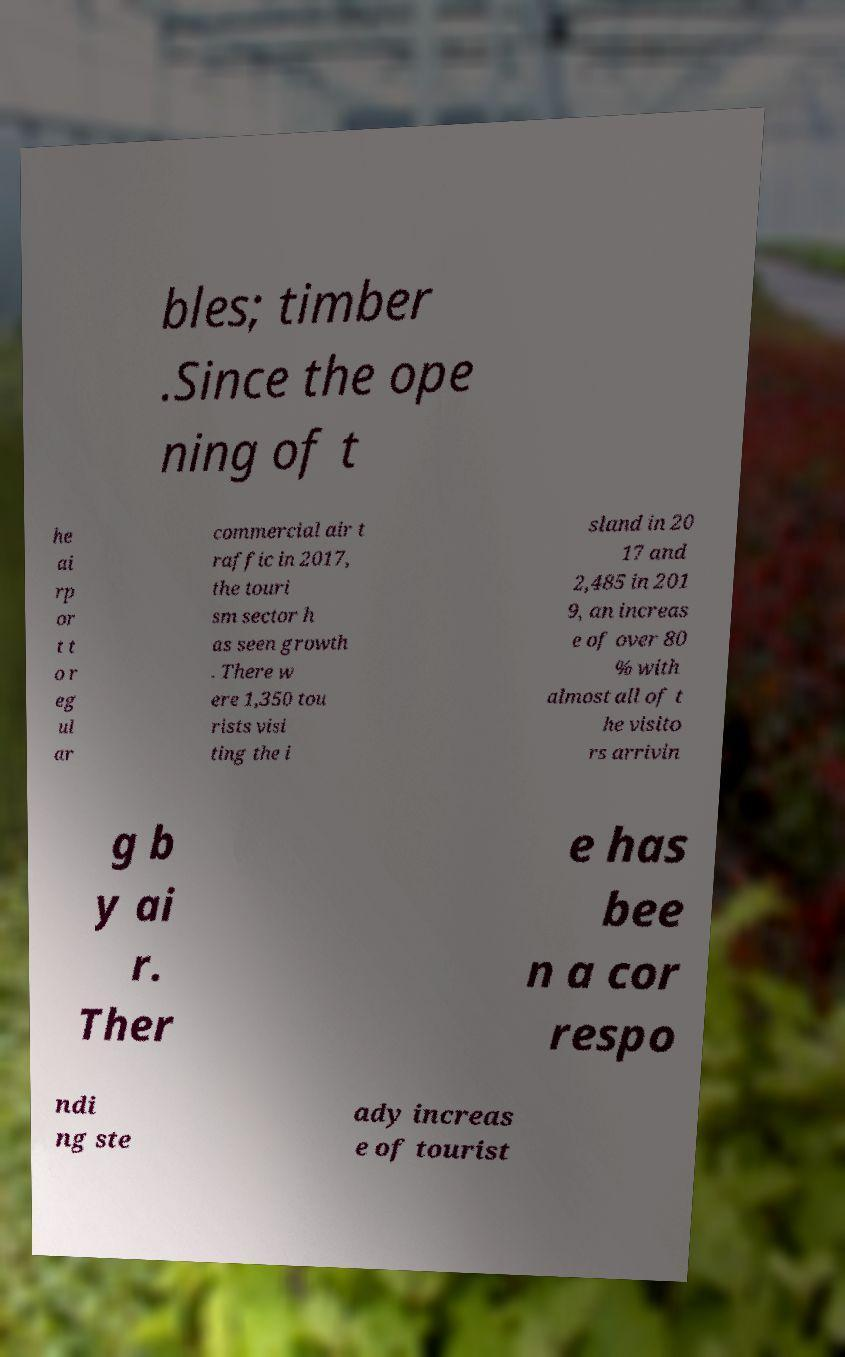I need the written content from this picture converted into text. Can you do that? bles; timber .Since the ope ning of t he ai rp or t t o r eg ul ar commercial air t raffic in 2017, the touri sm sector h as seen growth . There w ere 1,350 tou rists visi ting the i sland in 20 17 and 2,485 in 201 9, an increas e of over 80 % with almost all of t he visito rs arrivin g b y ai r. Ther e has bee n a cor respo ndi ng ste ady increas e of tourist 